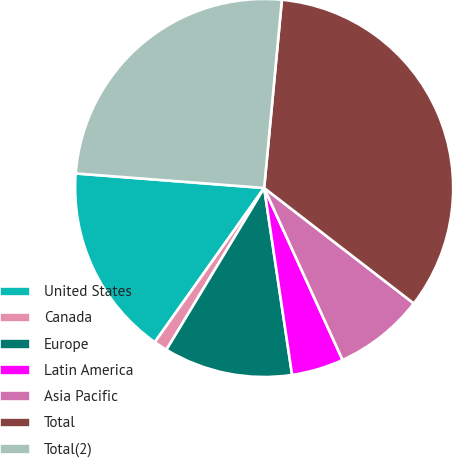Convert chart to OTSL. <chart><loc_0><loc_0><loc_500><loc_500><pie_chart><fcel>United States<fcel>Canada<fcel>Europe<fcel>Latin America<fcel>Asia Pacific<fcel>Total<fcel>Total(2)<nl><fcel>16.41%<fcel>1.17%<fcel>11.01%<fcel>4.45%<fcel>7.73%<fcel>33.97%<fcel>25.27%<nl></chart> 